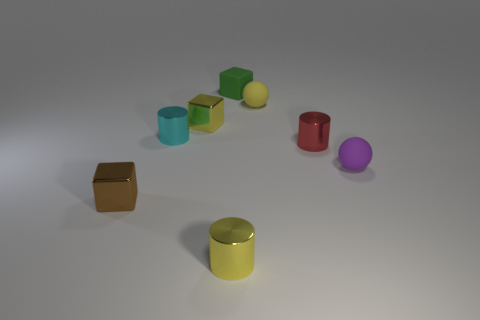Can you tell me the colors of the blocks in the image? Certainly! In the image, there is a variety of colored blocks. Starting from the left, there is a brown square block, followed by a small matte green cube, a smaller yellow sphere, a cyan cylinder, a purple sphere, a red cylinder, and a yellow-green cylinder. 